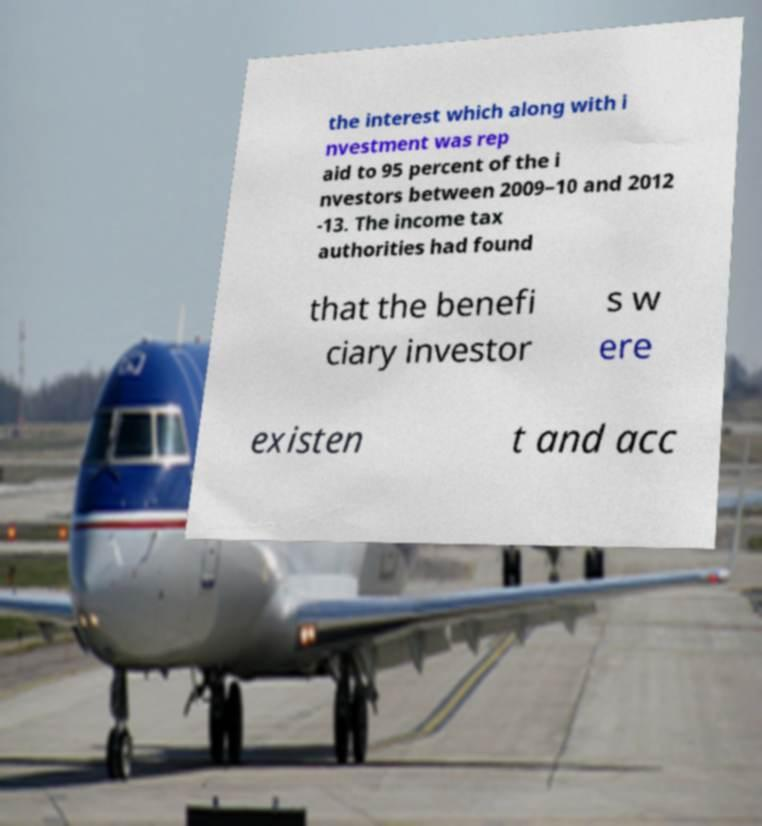For documentation purposes, I need the text within this image transcribed. Could you provide that? the interest which along with i nvestment was rep aid to 95 percent of the i nvestors between 2009–10 and 2012 -13. The income tax authorities had found that the benefi ciary investor s w ere existen t and acc 